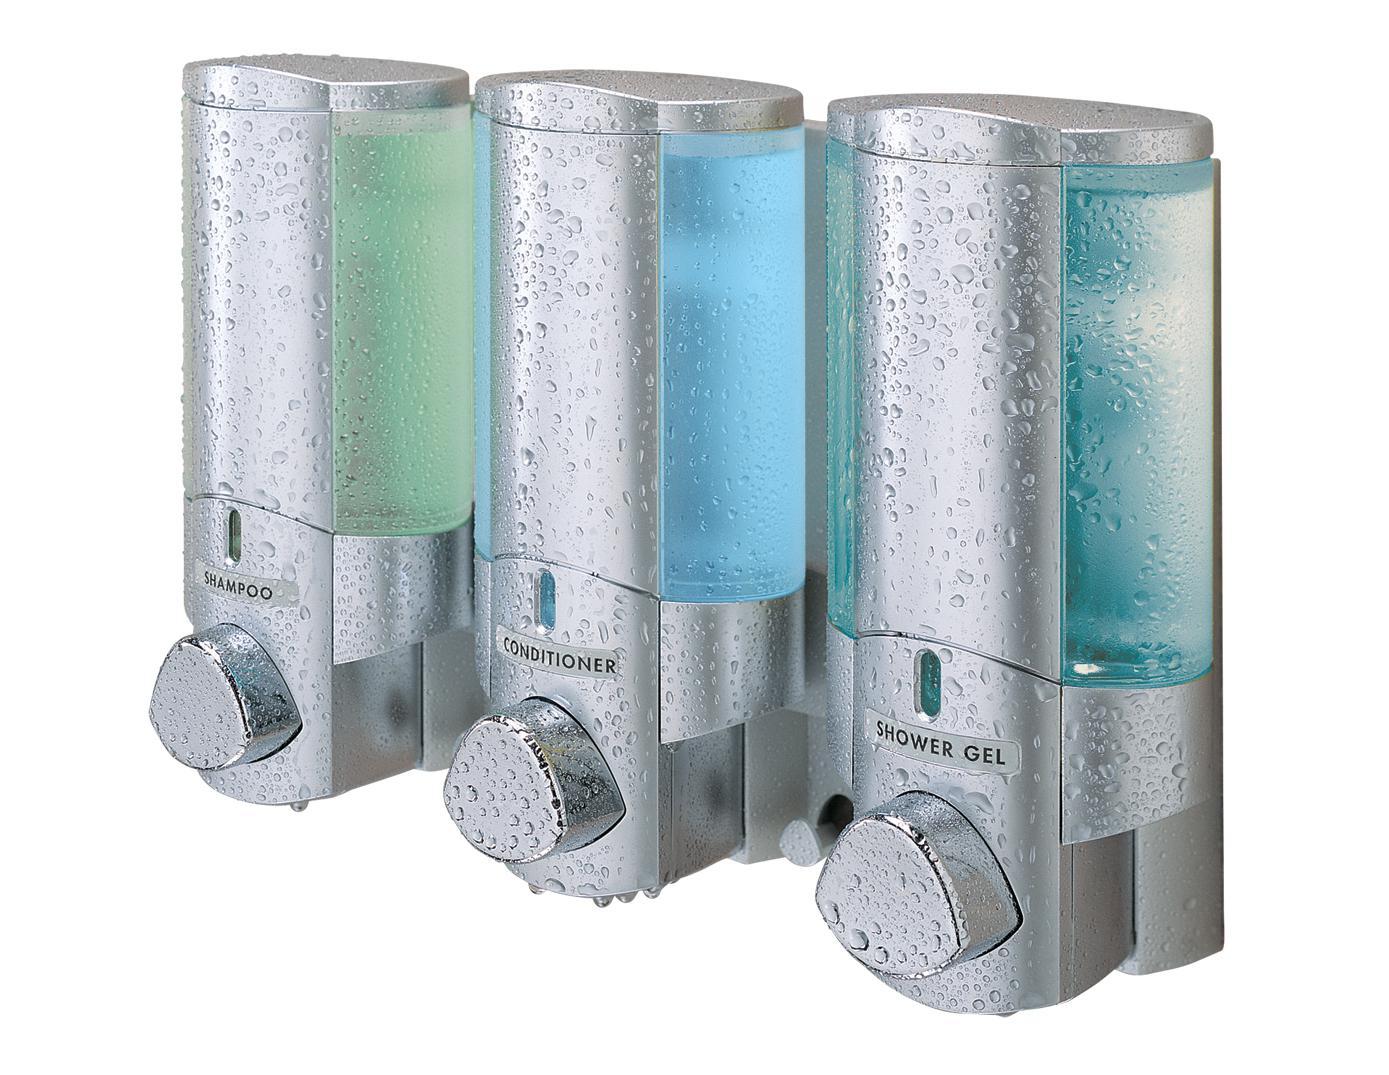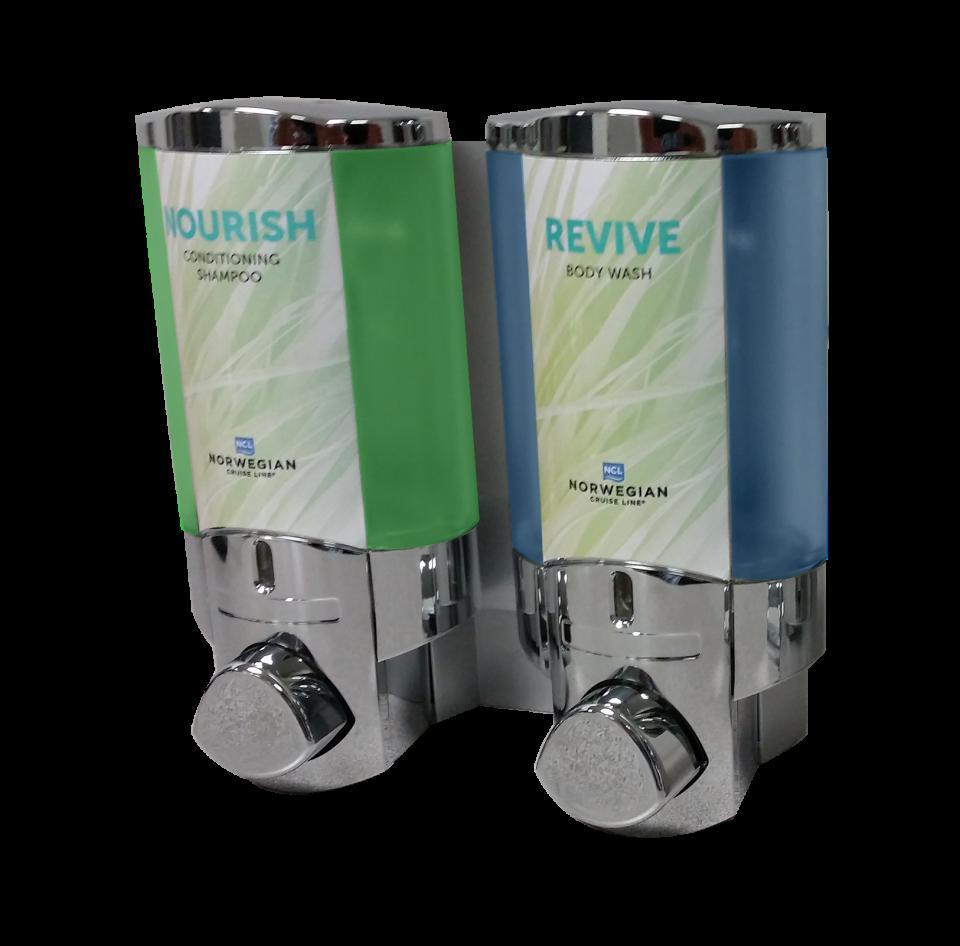The first image is the image on the left, the second image is the image on the right. Given the left and right images, does the statement "There are three dispensers in the image on the right." hold true? Answer yes or no. No. The first image is the image on the left, the second image is the image on the right. Analyze the images presented: Is the assertion "Five bathroom dispensers are divided into groups of two and three, each grouping having at least one liquid color in common with the other." valid? Answer yes or no. Yes. 